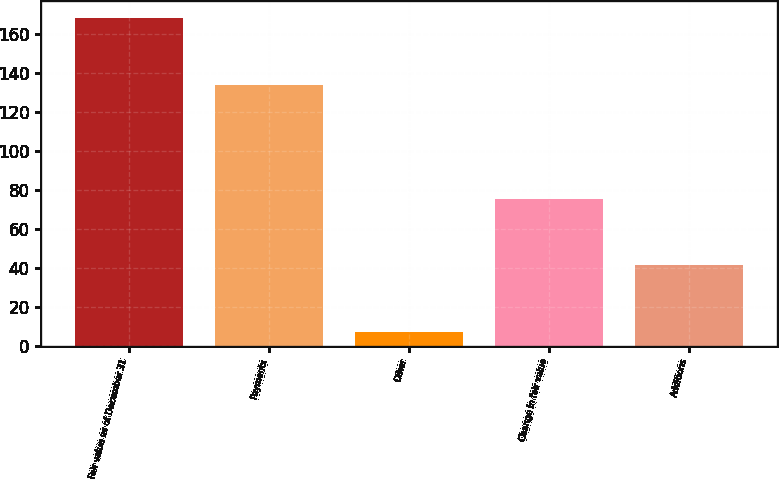<chart> <loc_0><loc_0><loc_500><loc_500><bar_chart><fcel>Fair value as of December 31<fcel>Payments<fcel>Other<fcel>Change in fair value<fcel>Additions<nl><fcel>168.2<fcel>134<fcel>7<fcel>75.4<fcel>41.2<nl></chart> 